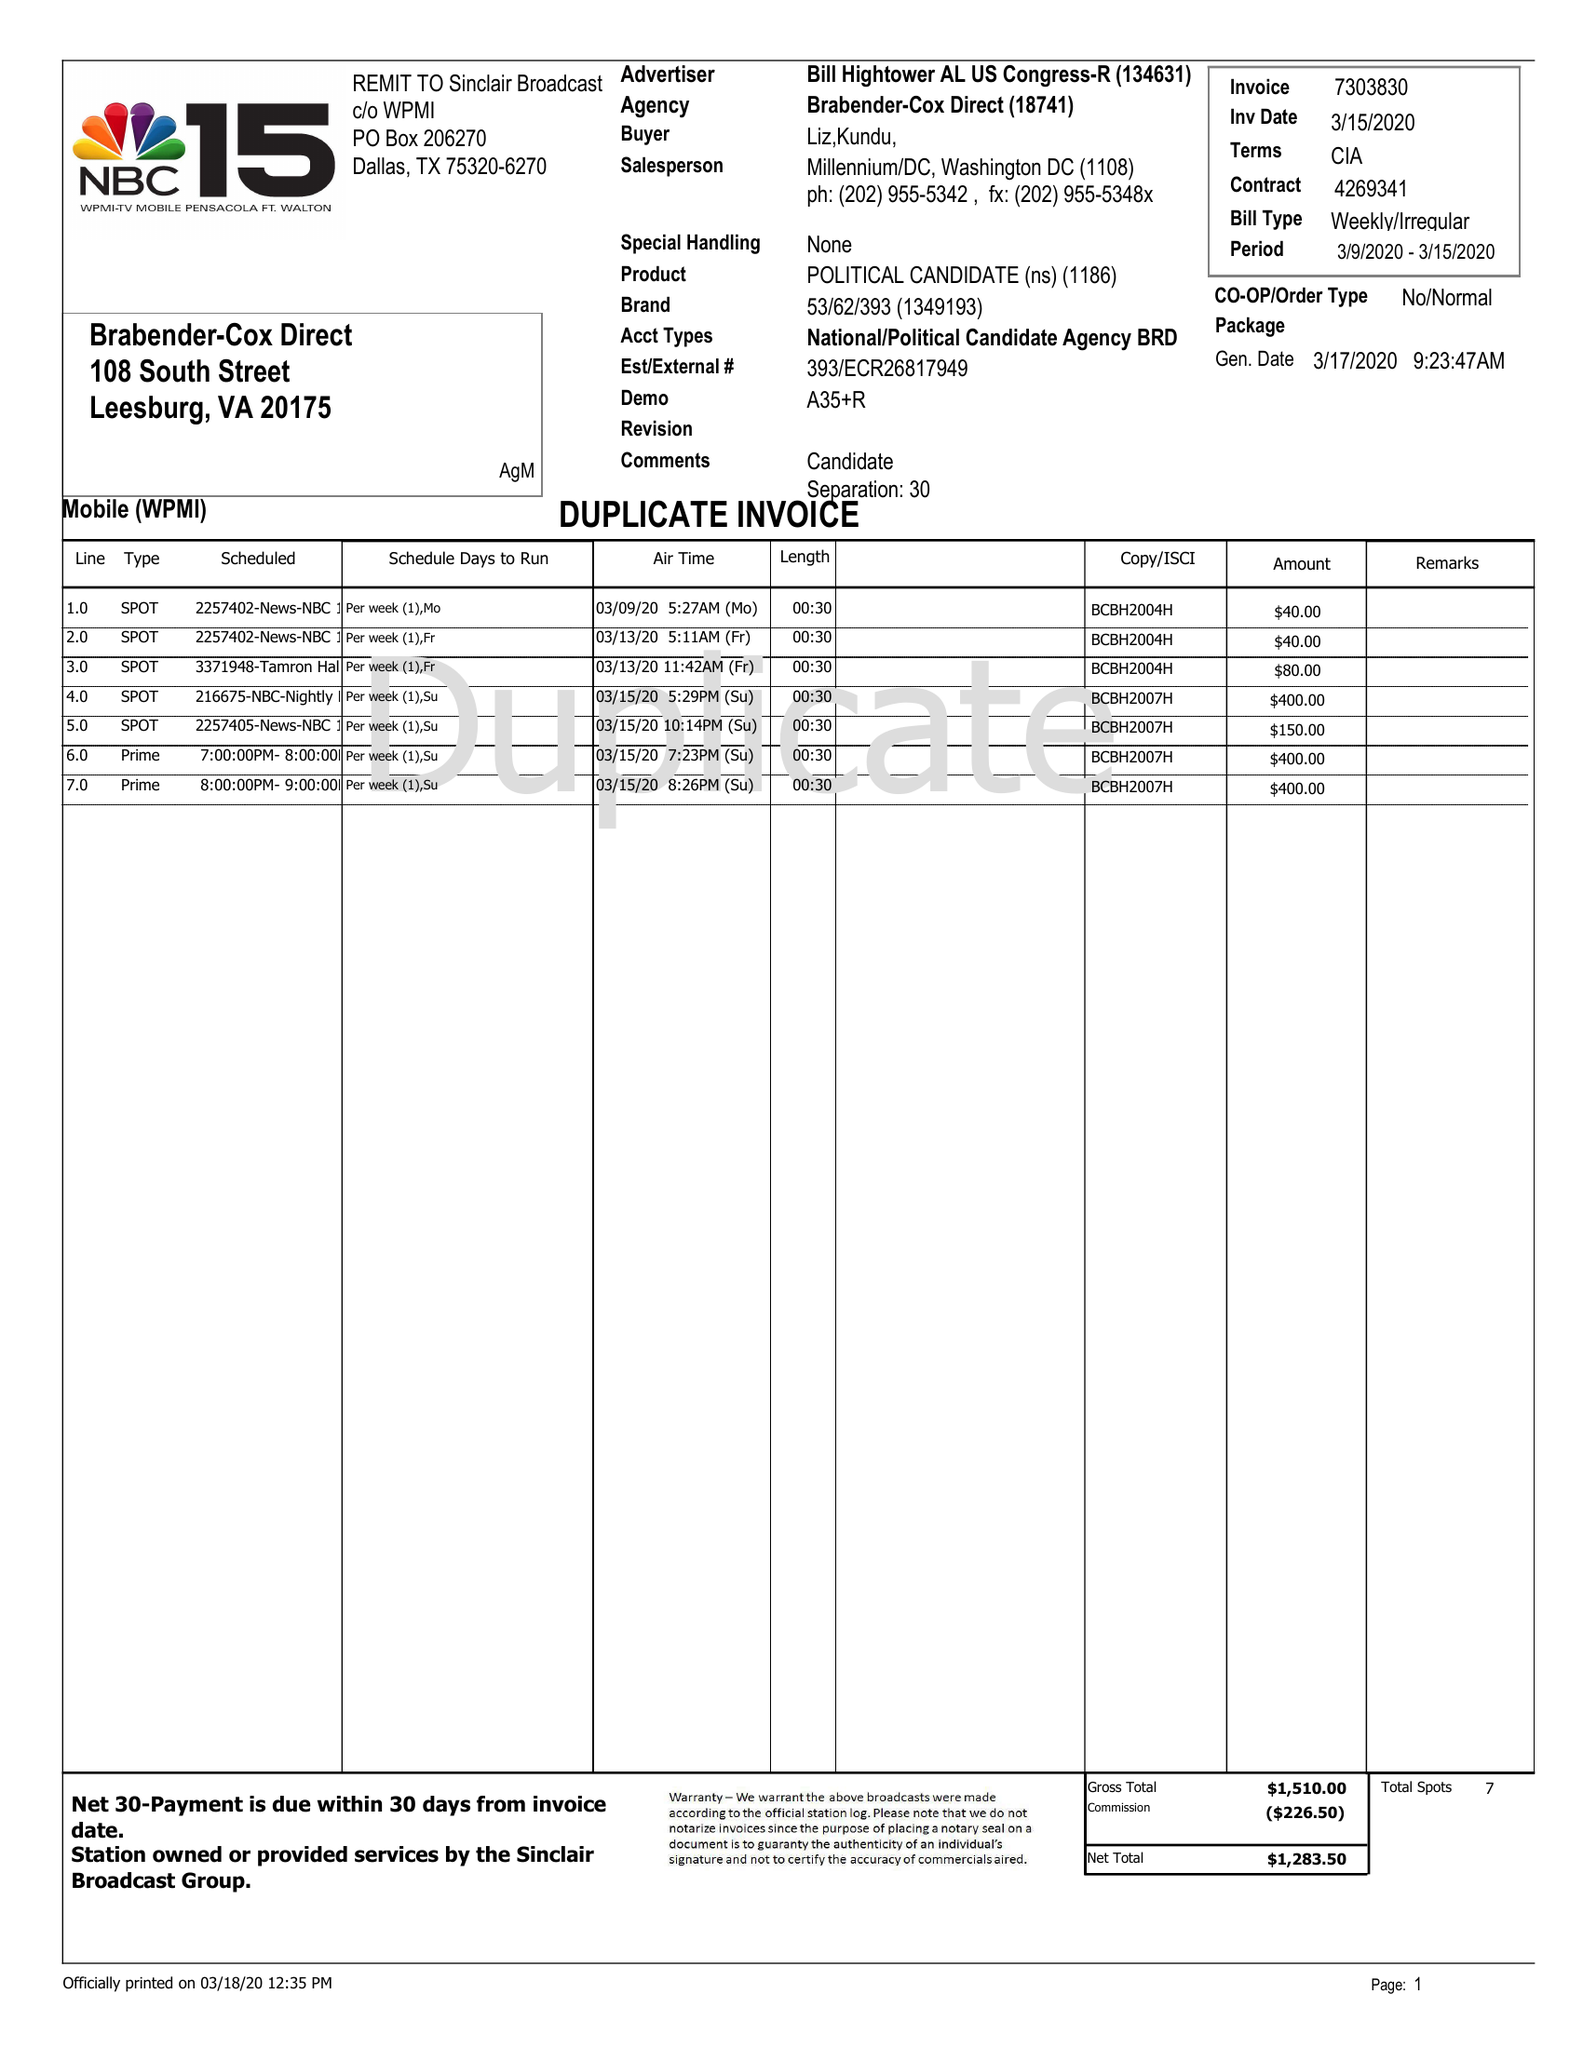What is the value for the flight_to?
Answer the question using a single word or phrase. 03/15/20 